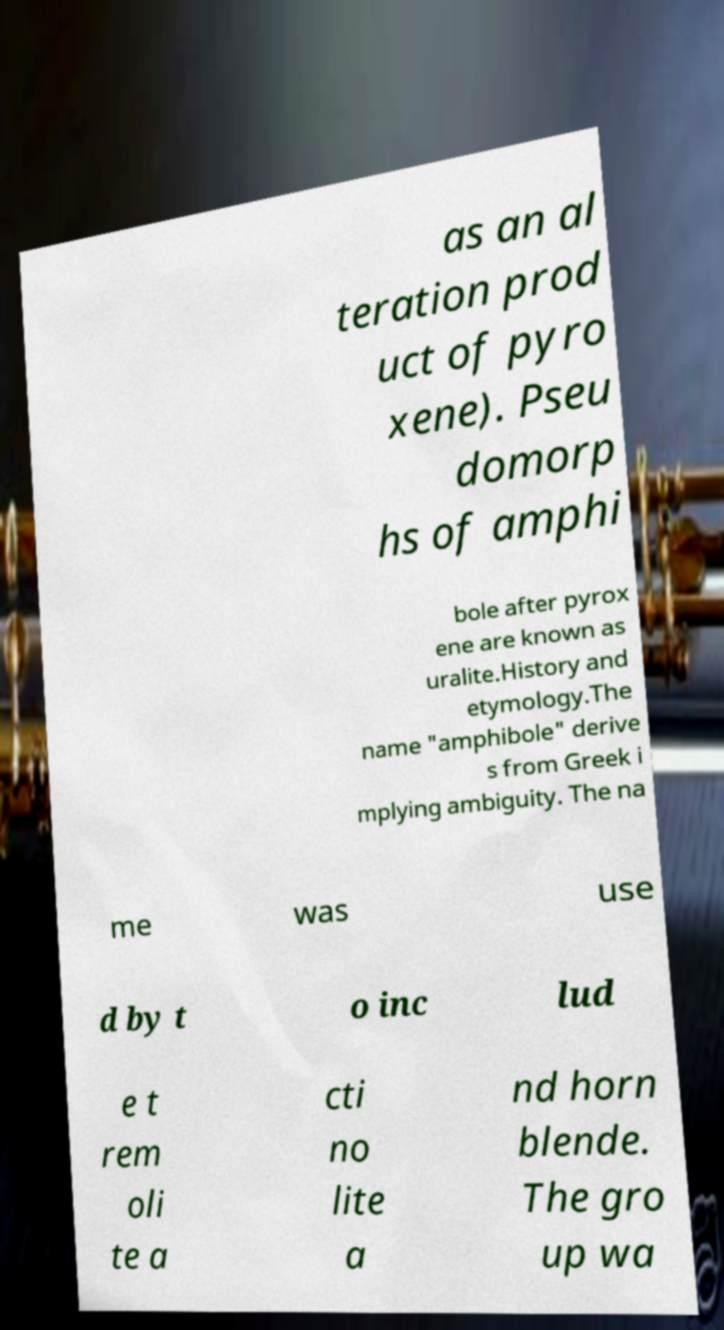For documentation purposes, I need the text within this image transcribed. Could you provide that? as an al teration prod uct of pyro xene). Pseu domorp hs of amphi bole after pyrox ene are known as uralite.History and etymology.The name "amphibole" derive s from Greek i mplying ambiguity. The na me was use d by t o inc lud e t rem oli te a cti no lite a nd horn blende. The gro up wa 